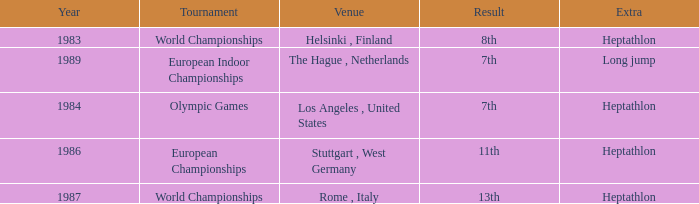Where was the 1984 Olympics hosted? Olympic Games. 